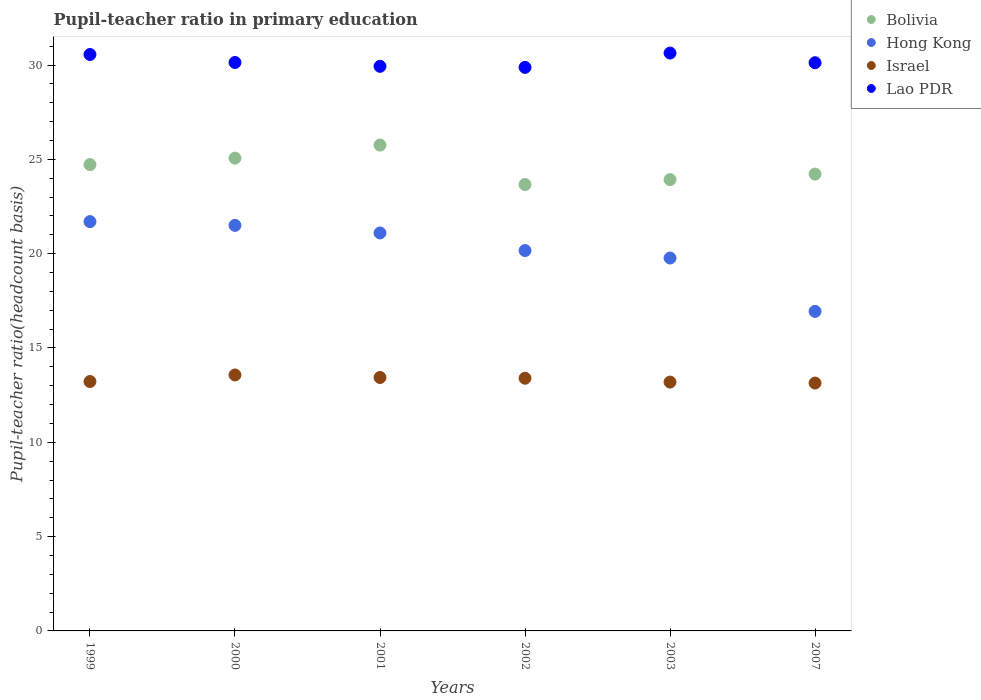Is the number of dotlines equal to the number of legend labels?
Ensure brevity in your answer.  Yes. What is the pupil-teacher ratio in primary education in Israel in 2001?
Your answer should be compact. 13.44. Across all years, what is the maximum pupil-teacher ratio in primary education in Lao PDR?
Keep it short and to the point. 30.64. Across all years, what is the minimum pupil-teacher ratio in primary education in Lao PDR?
Make the answer very short. 29.88. What is the total pupil-teacher ratio in primary education in Hong Kong in the graph?
Provide a short and direct response. 121.18. What is the difference between the pupil-teacher ratio in primary education in Hong Kong in 2001 and that in 2007?
Offer a very short reply. 4.16. What is the difference between the pupil-teacher ratio in primary education in Hong Kong in 2001 and the pupil-teacher ratio in primary education in Israel in 2007?
Offer a very short reply. 7.96. What is the average pupil-teacher ratio in primary education in Israel per year?
Provide a short and direct response. 13.33. In the year 1999, what is the difference between the pupil-teacher ratio in primary education in Israel and pupil-teacher ratio in primary education in Bolivia?
Offer a terse response. -11.5. In how many years, is the pupil-teacher ratio in primary education in Bolivia greater than 23?
Your response must be concise. 6. What is the ratio of the pupil-teacher ratio in primary education in Lao PDR in 2000 to that in 2003?
Your response must be concise. 0.98. Is the pupil-teacher ratio in primary education in Lao PDR in 2001 less than that in 2003?
Provide a succinct answer. Yes. Is the difference between the pupil-teacher ratio in primary education in Israel in 2000 and 2007 greater than the difference between the pupil-teacher ratio in primary education in Bolivia in 2000 and 2007?
Offer a very short reply. No. What is the difference between the highest and the second highest pupil-teacher ratio in primary education in Hong Kong?
Provide a short and direct response. 0.2. What is the difference between the highest and the lowest pupil-teacher ratio in primary education in Bolivia?
Make the answer very short. 2.09. Is the sum of the pupil-teacher ratio in primary education in Bolivia in 1999 and 2000 greater than the maximum pupil-teacher ratio in primary education in Hong Kong across all years?
Give a very brief answer. Yes. Is it the case that in every year, the sum of the pupil-teacher ratio in primary education in Bolivia and pupil-teacher ratio in primary education in Lao PDR  is greater than the sum of pupil-teacher ratio in primary education in Hong Kong and pupil-teacher ratio in primary education in Israel?
Offer a very short reply. Yes. Is the pupil-teacher ratio in primary education in Lao PDR strictly greater than the pupil-teacher ratio in primary education in Israel over the years?
Offer a terse response. Yes. Is the pupil-teacher ratio in primary education in Bolivia strictly less than the pupil-teacher ratio in primary education in Lao PDR over the years?
Keep it short and to the point. Yes. Where does the legend appear in the graph?
Ensure brevity in your answer.  Top right. How many legend labels are there?
Your answer should be very brief. 4. What is the title of the graph?
Provide a short and direct response. Pupil-teacher ratio in primary education. What is the label or title of the X-axis?
Ensure brevity in your answer.  Years. What is the label or title of the Y-axis?
Provide a short and direct response. Pupil-teacher ratio(headcount basis). What is the Pupil-teacher ratio(headcount basis) in Bolivia in 1999?
Give a very brief answer. 24.72. What is the Pupil-teacher ratio(headcount basis) of Hong Kong in 1999?
Provide a short and direct response. 21.7. What is the Pupil-teacher ratio(headcount basis) in Israel in 1999?
Provide a succinct answer. 13.22. What is the Pupil-teacher ratio(headcount basis) of Lao PDR in 1999?
Give a very brief answer. 30.56. What is the Pupil-teacher ratio(headcount basis) in Bolivia in 2000?
Give a very brief answer. 25.07. What is the Pupil-teacher ratio(headcount basis) of Hong Kong in 2000?
Your answer should be very brief. 21.5. What is the Pupil-teacher ratio(headcount basis) in Israel in 2000?
Your response must be concise. 13.57. What is the Pupil-teacher ratio(headcount basis) of Lao PDR in 2000?
Give a very brief answer. 30.14. What is the Pupil-teacher ratio(headcount basis) in Bolivia in 2001?
Make the answer very short. 25.76. What is the Pupil-teacher ratio(headcount basis) in Hong Kong in 2001?
Your answer should be compact. 21.1. What is the Pupil-teacher ratio(headcount basis) of Israel in 2001?
Give a very brief answer. 13.44. What is the Pupil-teacher ratio(headcount basis) of Lao PDR in 2001?
Provide a succinct answer. 29.93. What is the Pupil-teacher ratio(headcount basis) in Bolivia in 2002?
Give a very brief answer. 23.67. What is the Pupil-teacher ratio(headcount basis) in Hong Kong in 2002?
Provide a succinct answer. 20.17. What is the Pupil-teacher ratio(headcount basis) of Israel in 2002?
Offer a terse response. 13.4. What is the Pupil-teacher ratio(headcount basis) in Lao PDR in 2002?
Offer a terse response. 29.88. What is the Pupil-teacher ratio(headcount basis) in Bolivia in 2003?
Ensure brevity in your answer.  23.93. What is the Pupil-teacher ratio(headcount basis) of Hong Kong in 2003?
Offer a terse response. 19.77. What is the Pupil-teacher ratio(headcount basis) in Israel in 2003?
Your response must be concise. 13.19. What is the Pupil-teacher ratio(headcount basis) of Lao PDR in 2003?
Offer a very short reply. 30.64. What is the Pupil-teacher ratio(headcount basis) of Bolivia in 2007?
Offer a very short reply. 24.22. What is the Pupil-teacher ratio(headcount basis) of Hong Kong in 2007?
Your answer should be compact. 16.94. What is the Pupil-teacher ratio(headcount basis) in Israel in 2007?
Ensure brevity in your answer.  13.14. What is the Pupil-teacher ratio(headcount basis) in Lao PDR in 2007?
Your answer should be compact. 30.12. Across all years, what is the maximum Pupil-teacher ratio(headcount basis) of Bolivia?
Your answer should be very brief. 25.76. Across all years, what is the maximum Pupil-teacher ratio(headcount basis) of Hong Kong?
Ensure brevity in your answer.  21.7. Across all years, what is the maximum Pupil-teacher ratio(headcount basis) in Israel?
Give a very brief answer. 13.57. Across all years, what is the maximum Pupil-teacher ratio(headcount basis) of Lao PDR?
Provide a short and direct response. 30.64. Across all years, what is the minimum Pupil-teacher ratio(headcount basis) in Bolivia?
Offer a terse response. 23.67. Across all years, what is the minimum Pupil-teacher ratio(headcount basis) in Hong Kong?
Keep it short and to the point. 16.94. Across all years, what is the minimum Pupil-teacher ratio(headcount basis) in Israel?
Your answer should be compact. 13.14. Across all years, what is the minimum Pupil-teacher ratio(headcount basis) in Lao PDR?
Offer a terse response. 29.88. What is the total Pupil-teacher ratio(headcount basis) in Bolivia in the graph?
Offer a terse response. 147.36. What is the total Pupil-teacher ratio(headcount basis) of Hong Kong in the graph?
Provide a short and direct response. 121.18. What is the total Pupil-teacher ratio(headcount basis) in Israel in the graph?
Make the answer very short. 79.96. What is the total Pupil-teacher ratio(headcount basis) in Lao PDR in the graph?
Give a very brief answer. 181.27. What is the difference between the Pupil-teacher ratio(headcount basis) in Bolivia in 1999 and that in 2000?
Make the answer very short. -0.34. What is the difference between the Pupil-teacher ratio(headcount basis) of Hong Kong in 1999 and that in 2000?
Offer a terse response. 0.2. What is the difference between the Pupil-teacher ratio(headcount basis) of Israel in 1999 and that in 2000?
Make the answer very short. -0.35. What is the difference between the Pupil-teacher ratio(headcount basis) of Lao PDR in 1999 and that in 2000?
Offer a very short reply. 0.42. What is the difference between the Pupil-teacher ratio(headcount basis) of Bolivia in 1999 and that in 2001?
Your answer should be very brief. -1.04. What is the difference between the Pupil-teacher ratio(headcount basis) in Hong Kong in 1999 and that in 2001?
Offer a very short reply. 0.6. What is the difference between the Pupil-teacher ratio(headcount basis) of Israel in 1999 and that in 2001?
Your answer should be very brief. -0.21. What is the difference between the Pupil-teacher ratio(headcount basis) in Lao PDR in 1999 and that in 2001?
Offer a terse response. 0.63. What is the difference between the Pupil-teacher ratio(headcount basis) in Bolivia in 1999 and that in 2002?
Provide a succinct answer. 1.06. What is the difference between the Pupil-teacher ratio(headcount basis) in Hong Kong in 1999 and that in 2002?
Provide a succinct answer. 1.53. What is the difference between the Pupil-teacher ratio(headcount basis) of Israel in 1999 and that in 2002?
Offer a very short reply. -0.17. What is the difference between the Pupil-teacher ratio(headcount basis) in Lao PDR in 1999 and that in 2002?
Offer a very short reply. 0.68. What is the difference between the Pupil-teacher ratio(headcount basis) of Bolivia in 1999 and that in 2003?
Offer a very short reply. 0.8. What is the difference between the Pupil-teacher ratio(headcount basis) of Hong Kong in 1999 and that in 2003?
Your response must be concise. 1.93. What is the difference between the Pupil-teacher ratio(headcount basis) of Israel in 1999 and that in 2003?
Your answer should be compact. 0.03. What is the difference between the Pupil-teacher ratio(headcount basis) of Lao PDR in 1999 and that in 2003?
Ensure brevity in your answer.  -0.08. What is the difference between the Pupil-teacher ratio(headcount basis) of Bolivia in 1999 and that in 2007?
Ensure brevity in your answer.  0.5. What is the difference between the Pupil-teacher ratio(headcount basis) in Hong Kong in 1999 and that in 2007?
Ensure brevity in your answer.  4.76. What is the difference between the Pupil-teacher ratio(headcount basis) in Israel in 1999 and that in 2007?
Your response must be concise. 0.08. What is the difference between the Pupil-teacher ratio(headcount basis) in Lao PDR in 1999 and that in 2007?
Your answer should be compact. 0.44. What is the difference between the Pupil-teacher ratio(headcount basis) of Bolivia in 2000 and that in 2001?
Make the answer very short. -0.69. What is the difference between the Pupil-teacher ratio(headcount basis) in Hong Kong in 2000 and that in 2001?
Provide a short and direct response. 0.4. What is the difference between the Pupil-teacher ratio(headcount basis) in Israel in 2000 and that in 2001?
Your response must be concise. 0.13. What is the difference between the Pupil-teacher ratio(headcount basis) of Lao PDR in 2000 and that in 2001?
Offer a very short reply. 0.2. What is the difference between the Pupil-teacher ratio(headcount basis) in Bolivia in 2000 and that in 2002?
Provide a succinct answer. 1.4. What is the difference between the Pupil-teacher ratio(headcount basis) of Hong Kong in 2000 and that in 2002?
Your answer should be compact. 1.33. What is the difference between the Pupil-teacher ratio(headcount basis) of Israel in 2000 and that in 2002?
Make the answer very short. 0.17. What is the difference between the Pupil-teacher ratio(headcount basis) of Lao PDR in 2000 and that in 2002?
Your response must be concise. 0.26. What is the difference between the Pupil-teacher ratio(headcount basis) of Bolivia in 2000 and that in 2003?
Your answer should be very brief. 1.14. What is the difference between the Pupil-teacher ratio(headcount basis) of Hong Kong in 2000 and that in 2003?
Your response must be concise. 1.73. What is the difference between the Pupil-teacher ratio(headcount basis) of Israel in 2000 and that in 2003?
Ensure brevity in your answer.  0.38. What is the difference between the Pupil-teacher ratio(headcount basis) of Lao PDR in 2000 and that in 2003?
Your response must be concise. -0.5. What is the difference between the Pupil-teacher ratio(headcount basis) in Bolivia in 2000 and that in 2007?
Provide a succinct answer. 0.85. What is the difference between the Pupil-teacher ratio(headcount basis) in Hong Kong in 2000 and that in 2007?
Offer a very short reply. 4.56. What is the difference between the Pupil-teacher ratio(headcount basis) in Israel in 2000 and that in 2007?
Offer a terse response. 0.43. What is the difference between the Pupil-teacher ratio(headcount basis) in Lao PDR in 2000 and that in 2007?
Provide a succinct answer. 0.01. What is the difference between the Pupil-teacher ratio(headcount basis) of Bolivia in 2001 and that in 2002?
Your answer should be very brief. 2.09. What is the difference between the Pupil-teacher ratio(headcount basis) of Hong Kong in 2001 and that in 2002?
Ensure brevity in your answer.  0.93. What is the difference between the Pupil-teacher ratio(headcount basis) of Israel in 2001 and that in 2002?
Make the answer very short. 0.04. What is the difference between the Pupil-teacher ratio(headcount basis) of Lao PDR in 2001 and that in 2002?
Offer a very short reply. 0.06. What is the difference between the Pupil-teacher ratio(headcount basis) of Bolivia in 2001 and that in 2003?
Offer a terse response. 1.83. What is the difference between the Pupil-teacher ratio(headcount basis) in Hong Kong in 2001 and that in 2003?
Offer a terse response. 1.33. What is the difference between the Pupil-teacher ratio(headcount basis) of Israel in 2001 and that in 2003?
Make the answer very short. 0.24. What is the difference between the Pupil-teacher ratio(headcount basis) in Lao PDR in 2001 and that in 2003?
Offer a very short reply. -0.7. What is the difference between the Pupil-teacher ratio(headcount basis) of Bolivia in 2001 and that in 2007?
Provide a short and direct response. 1.54. What is the difference between the Pupil-teacher ratio(headcount basis) of Hong Kong in 2001 and that in 2007?
Provide a short and direct response. 4.16. What is the difference between the Pupil-teacher ratio(headcount basis) in Israel in 2001 and that in 2007?
Your answer should be very brief. 0.29. What is the difference between the Pupil-teacher ratio(headcount basis) of Lao PDR in 2001 and that in 2007?
Offer a very short reply. -0.19. What is the difference between the Pupil-teacher ratio(headcount basis) of Bolivia in 2002 and that in 2003?
Offer a terse response. -0.26. What is the difference between the Pupil-teacher ratio(headcount basis) of Hong Kong in 2002 and that in 2003?
Your answer should be very brief. 0.4. What is the difference between the Pupil-teacher ratio(headcount basis) in Israel in 2002 and that in 2003?
Make the answer very short. 0.2. What is the difference between the Pupil-teacher ratio(headcount basis) of Lao PDR in 2002 and that in 2003?
Make the answer very short. -0.76. What is the difference between the Pupil-teacher ratio(headcount basis) in Bolivia in 2002 and that in 2007?
Offer a very short reply. -0.55. What is the difference between the Pupil-teacher ratio(headcount basis) in Hong Kong in 2002 and that in 2007?
Provide a short and direct response. 3.23. What is the difference between the Pupil-teacher ratio(headcount basis) of Israel in 2002 and that in 2007?
Provide a succinct answer. 0.26. What is the difference between the Pupil-teacher ratio(headcount basis) in Lao PDR in 2002 and that in 2007?
Your answer should be compact. -0.25. What is the difference between the Pupil-teacher ratio(headcount basis) of Bolivia in 2003 and that in 2007?
Offer a terse response. -0.29. What is the difference between the Pupil-teacher ratio(headcount basis) in Hong Kong in 2003 and that in 2007?
Offer a very short reply. 2.83. What is the difference between the Pupil-teacher ratio(headcount basis) in Israel in 2003 and that in 2007?
Your response must be concise. 0.05. What is the difference between the Pupil-teacher ratio(headcount basis) of Lao PDR in 2003 and that in 2007?
Offer a very short reply. 0.51. What is the difference between the Pupil-teacher ratio(headcount basis) in Bolivia in 1999 and the Pupil-teacher ratio(headcount basis) in Hong Kong in 2000?
Make the answer very short. 3.22. What is the difference between the Pupil-teacher ratio(headcount basis) of Bolivia in 1999 and the Pupil-teacher ratio(headcount basis) of Israel in 2000?
Offer a terse response. 11.15. What is the difference between the Pupil-teacher ratio(headcount basis) in Bolivia in 1999 and the Pupil-teacher ratio(headcount basis) in Lao PDR in 2000?
Give a very brief answer. -5.41. What is the difference between the Pupil-teacher ratio(headcount basis) of Hong Kong in 1999 and the Pupil-teacher ratio(headcount basis) of Israel in 2000?
Give a very brief answer. 8.13. What is the difference between the Pupil-teacher ratio(headcount basis) in Hong Kong in 1999 and the Pupil-teacher ratio(headcount basis) in Lao PDR in 2000?
Make the answer very short. -8.44. What is the difference between the Pupil-teacher ratio(headcount basis) of Israel in 1999 and the Pupil-teacher ratio(headcount basis) of Lao PDR in 2000?
Make the answer very short. -16.91. What is the difference between the Pupil-teacher ratio(headcount basis) in Bolivia in 1999 and the Pupil-teacher ratio(headcount basis) in Hong Kong in 2001?
Provide a succinct answer. 3.62. What is the difference between the Pupil-teacher ratio(headcount basis) in Bolivia in 1999 and the Pupil-teacher ratio(headcount basis) in Israel in 2001?
Your answer should be very brief. 11.29. What is the difference between the Pupil-teacher ratio(headcount basis) in Bolivia in 1999 and the Pupil-teacher ratio(headcount basis) in Lao PDR in 2001?
Offer a terse response. -5.21. What is the difference between the Pupil-teacher ratio(headcount basis) of Hong Kong in 1999 and the Pupil-teacher ratio(headcount basis) of Israel in 2001?
Give a very brief answer. 8.26. What is the difference between the Pupil-teacher ratio(headcount basis) of Hong Kong in 1999 and the Pupil-teacher ratio(headcount basis) of Lao PDR in 2001?
Provide a short and direct response. -8.23. What is the difference between the Pupil-teacher ratio(headcount basis) in Israel in 1999 and the Pupil-teacher ratio(headcount basis) in Lao PDR in 2001?
Give a very brief answer. -16.71. What is the difference between the Pupil-teacher ratio(headcount basis) in Bolivia in 1999 and the Pupil-teacher ratio(headcount basis) in Hong Kong in 2002?
Your answer should be compact. 4.56. What is the difference between the Pupil-teacher ratio(headcount basis) of Bolivia in 1999 and the Pupil-teacher ratio(headcount basis) of Israel in 2002?
Your answer should be compact. 11.33. What is the difference between the Pupil-teacher ratio(headcount basis) of Bolivia in 1999 and the Pupil-teacher ratio(headcount basis) of Lao PDR in 2002?
Ensure brevity in your answer.  -5.15. What is the difference between the Pupil-teacher ratio(headcount basis) of Hong Kong in 1999 and the Pupil-teacher ratio(headcount basis) of Israel in 2002?
Your response must be concise. 8.3. What is the difference between the Pupil-teacher ratio(headcount basis) of Hong Kong in 1999 and the Pupil-teacher ratio(headcount basis) of Lao PDR in 2002?
Your answer should be very brief. -8.18. What is the difference between the Pupil-teacher ratio(headcount basis) of Israel in 1999 and the Pupil-teacher ratio(headcount basis) of Lao PDR in 2002?
Your answer should be very brief. -16.65. What is the difference between the Pupil-teacher ratio(headcount basis) of Bolivia in 1999 and the Pupil-teacher ratio(headcount basis) of Hong Kong in 2003?
Keep it short and to the point. 4.95. What is the difference between the Pupil-teacher ratio(headcount basis) of Bolivia in 1999 and the Pupil-teacher ratio(headcount basis) of Israel in 2003?
Offer a very short reply. 11.53. What is the difference between the Pupil-teacher ratio(headcount basis) in Bolivia in 1999 and the Pupil-teacher ratio(headcount basis) in Lao PDR in 2003?
Ensure brevity in your answer.  -5.91. What is the difference between the Pupil-teacher ratio(headcount basis) in Hong Kong in 1999 and the Pupil-teacher ratio(headcount basis) in Israel in 2003?
Your answer should be compact. 8.51. What is the difference between the Pupil-teacher ratio(headcount basis) of Hong Kong in 1999 and the Pupil-teacher ratio(headcount basis) of Lao PDR in 2003?
Provide a succinct answer. -8.94. What is the difference between the Pupil-teacher ratio(headcount basis) in Israel in 1999 and the Pupil-teacher ratio(headcount basis) in Lao PDR in 2003?
Provide a short and direct response. -17.41. What is the difference between the Pupil-teacher ratio(headcount basis) in Bolivia in 1999 and the Pupil-teacher ratio(headcount basis) in Hong Kong in 2007?
Offer a terse response. 7.78. What is the difference between the Pupil-teacher ratio(headcount basis) of Bolivia in 1999 and the Pupil-teacher ratio(headcount basis) of Israel in 2007?
Offer a terse response. 11.58. What is the difference between the Pupil-teacher ratio(headcount basis) of Bolivia in 1999 and the Pupil-teacher ratio(headcount basis) of Lao PDR in 2007?
Your answer should be very brief. -5.4. What is the difference between the Pupil-teacher ratio(headcount basis) of Hong Kong in 1999 and the Pupil-teacher ratio(headcount basis) of Israel in 2007?
Give a very brief answer. 8.56. What is the difference between the Pupil-teacher ratio(headcount basis) in Hong Kong in 1999 and the Pupil-teacher ratio(headcount basis) in Lao PDR in 2007?
Give a very brief answer. -8.42. What is the difference between the Pupil-teacher ratio(headcount basis) of Israel in 1999 and the Pupil-teacher ratio(headcount basis) of Lao PDR in 2007?
Your answer should be compact. -16.9. What is the difference between the Pupil-teacher ratio(headcount basis) of Bolivia in 2000 and the Pupil-teacher ratio(headcount basis) of Hong Kong in 2001?
Your response must be concise. 3.97. What is the difference between the Pupil-teacher ratio(headcount basis) of Bolivia in 2000 and the Pupil-teacher ratio(headcount basis) of Israel in 2001?
Provide a succinct answer. 11.63. What is the difference between the Pupil-teacher ratio(headcount basis) in Bolivia in 2000 and the Pupil-teacher ratio(headcount basis) in Lao PDR in 2001?
Make the answer very short. -4.87. What is the difference between the Pupil-teacher ratio(headcount basis) in Hong Kong in 2000 and the Pupil-teacher ratio(headcount basis) in Israel in 2001?
Ensure brevity in your answer.  8.06. What is the difference between the Pupil-teacher ratio(headcount basis) of Hong Kong in 2000 and the Pupil-teacher ratio(headcount basis) of Lao PDR in 2001?
Give a very brief answer. -8.43. What is the difference between the Pupil-teacher ratio(headcount basis) in Israel in 2000 and the Pupil-teacher ratio(headcount basis) in Lao PDR in 2001?
Ensure brevity in your answer.  -16.36. What is the difference between the Pupil-teacher ratio(headcount basis) in Bolivia in 2000 and the Pupil-teacher ratio(headcount basis) in Hong Kong in 2002?
Offer a terse response. 4.9. What is the difference between the Pupil-teacher ratio(headcount basis) in Bolivia in 2000 and the Pupil-teacher ratio(headcount basis) in Israel in 2002?
Ensure brevity in your answer.  11.67. What is the difference between the Pupil-teacher ratio(headcount basis) of Bolivia in 2000 and the Pupil-teacher ratio(headcount basis) of Lao PDR in 2002?
Provide a succinct answer. -4.81. What is the difference between the Pupil-teacher ratio(headcount basis) of Hong Kong in 2000 and the Pupil-teacher ratio(headcount basis) of Israel in 2002?
Provide a succinct answer. 8.1. What is the difference between the Pupil-teacher ratio(headcount basis) in Hong Kong in 2000 and the Pupil-teacher ratio(headcount basis) in Lao PDR in 2002?
Provide a succinct answer. -8.38. What is the difference between the Pupil-teacher ratio(headcount basis) of Israel in 2000 and the Pupil-teacher ratio(headcount basis) of Lao PDR in 2002?
Keep it short and to the point. -16.31. What is the difference between the Pupil-teacher ratio(headcount basis) in Bolivia in 2000 and the Pupil-teacher ratio(headcount basis) in Hong Kong in 2003?
Your response must be concise. 5.3. What is the difference between the Pupil-teacher ratio(headcount basis) in Bolivia in 2000 and the Pupil-teacher ratio(headcount basis) in Israel in 2003?
Offer a very short reply. 11.87. What is the difference between the Pupil-teacher ratio(headcount basis) in Bolivia in 2000 and the Pupil-teacher ratio(headcount basis) in Lao PDR in 2003?
Your response must be concise. -5.57. What is the difference between the Pupil-teacher ratio(headcount basis) of Hong Kong in 2000 and the Pupil-teacher ratio(headcount basis) of Israel in 2003?
Give a very brief answer. 8.31. What is the difference between the Pupil-teacher ratio(headcount basis) in Hong Kong in 2000 and the Pupil-teacher ratio(headcount basis) in Lao PDR in 2003?
Offer a terse response. -9.14. What is the difference between the Pupil-teacher ratio(headcount basis) of Israel in 2000 and the Pupil-teacher ratio(headcount basis) of Lao PDR in 2003?
Ensure brevity in your answer.  -17.07. What is the difference between the Pupil-teacher ratio(headcount basis) in Bolivia in 2000 and the Pupil-teacher ratio(headcount basis) in Hong Kong in 2007?
Make the answer very short. 8.12. What is the difference between the Pupil-teacher ratio(headcount basis) of Bolivia in 2000 and the Pupil-teacher ratio(headcount basis) of Israel in 2007?
Offer a terse response. 11.92. What is the difference between the Pupil-teacher ratio(headcount basis) in Bolivia in 2000 and the Pupil-teacher ratio(headcount basis) in Lao PDR in 2007?
Your response must be concise. -5.06. What is the difference between the Pupil-teacher ratio(headcount basis) in Hong Kong in 2000 and the Pupil-teacher ratio(headcount basis) in Israel in 2007?
Provide a short and direct response. 8.36. What is the difference between the Pupil-teacher ratio(headcount basis) in Hong Kong in 2000 and the Pupil-teacher ratio(headcount basis) in Lao PDR in 2007?
Your answer should be compact. -8.62. What is the difference between the Pupil-teacher ratio(headcount basis) of Israel in 2000 and the Pupil-teacher ratio(headcount basis) of Lao PDR in 2007?
Your answer should be compact. -16.55. What is the difference between the Pupil-teacher ratio(headcount basis) of Bolivia in 2001 and the Pupil-teacher ratio(headcount basis) of Hong Kong in 2002?
Your answer should be very brief. 5.59. What is the difference between the Pupil-teacher ratio(headcount basis) in Bolivia in 2001 and the Pupil-teacher ratio(headcount basis) in Israel in 2002?
Your answer should be compact. 12.36. What is the difference between the Pupil-teacher ratio(headcount basis) in Bolivia in 2001 and the Pupil-teacher ratio(headcount basis) in Lao PDR in 2002?
Provide a short and direct response. -4.12. What is the difference between the Pupil-teacher ratio(headcount basis) of Hong Kong in 2001 and the Pupil-teacher ratio(headcount basis) of Israel in 2002?
Give a very brief answer. 7.7. What is the difference between the Pupil-teacher ratio(headcount basis) of Hong Kong in 2001 and the Pupil-teacher ratio(headcount basis) of Lao PDR in 2002?
Provide a succinct answer. -8.78. What is the difference between the Pupil-teacher ratio(headcount basis) in Israel in 2001 and the Pupil-teacher ratio(headcount basis) in Lao PDR in 2002?
Make the answer very short. -16.44. What is the difference between the Pupil-teacher ratio(headcount basis) of Bolivia in 2001 and the Pupil-teacher ratio(headcount basis) of Hong Kong in 2003?
Your answer should be compact. 5.99. What is the difference between the Pupil-teacher ratio(headcount basis) of Bolivia in 2001 and the Pupil-teacher ratio(headcount basis) of Israel in 2003?
Keep it short and to the point. 12.57. What is the difference between the Pupil-teacher ratio(headcount basis) of Bolivia in 2001 and the Pupil-teacher ratio(headcount basis) of Lao PDR in 2003?
Provide a short and direct response. -4.88. What is the difference between the Pupil-teacher ratio(headcount basis) in Hong Kong in 2001 and the Pupil-teacher ratio(headcount basis) in Israel in 2003?
Give a very brief answer. 7.91. What is the difference between the Pupil-teacher ratio(headcount basis) of Hong Kong in 2001 and the Pupil-teacher ratio(headcount basis) of Lao PDR in 2003?
Give a very brief answer. -9.54. What is the difference between the Pupil-teacher ratio(headcount basis) in Israel in 2001 and the Pupil-teacher ratio(headcount basis) in Lao PDR in 2003?
Ensure brevity in your answer.  -17.2. What is the difference between the Pupil-teacher ratio(headcount basis) of Bolivia in 2001 and the Pupil-teacher ratio(headcount basis) of Hong Kong in 2007?
Your response must be concise. 8.82. What is the difference between the Pupil-teacher ratio(headcount basis) in Bolivia in 2001 and the Pupil-teacher ratio(headcount basis) in Israel in 2007?
Keep it short and to the point. 12.62. What is the difference between the Pupil-teacher ratio(headcount basis) of Bolivia in 2001 and the Pupil-teacher ratio(headcount basis) of Lao PDR in 2007?
Ensure brevity in your answer.  -4.36. What is the difference between the Pupil-teacher ratio(headcount basis) in Hong Kong in 2001 and the Pupil-teacher ratio(headcount basis) in Israel in 2007?
Provide a short and direct response. 7.96. What is the difference between the Pupil-teacher ratio(headcount basis) in Hong Kong in 2001 and the Pupil-teacher ratio(headcount basis) in Lao PDR in 2007?
Ensure brevity in your answer.  -9.03. What is the difference between the Pupil-teacher ratio(headcount basis) of Israel in 2001 and the Pupil-teacher ratio(headcount basis) of Lao PDR in 2007?
Your response must be concise. -16.69. What is the difference between the Pupil-teacher ratio(headcount basis) of Bolivia in 2002 and the Pupil-teacher ratio(headcount basis) of Hong Kong in 2003?
Make the answer very short. 3.9. What is the difference between the Pupil-teacher ratio(headcount basis) in Bolivia in 2002 and the Pupil-teacher ratio(headcount basis) in Israel in 2003?
Provide a succinct answer. 10.48. What is the difference between the Pupil-teacher ratio(headcount basis) of Bolivia in 2002 and the Pupil-teacher ratio(headcount basis) of Lao PDR in 2003?
Ensure brevity in your answer.  -6.97. What is the difference between the Pupil-teacher ratio(headcount basis) in Hong Kong in 2002 and the Pupil-teacher ratio(headcount basis) in Israel in 2003?
Provide a succinct answer. 6.97. What is the difference between the Pupil-teacher ratio(headcount basis) of Hong Kong in 2002 and the Pupil-teacher ratio(headcount basis) of Lao PDR in 2003?
Your response must be concise. -10.47. What is the difference between the Pupil-teacher ratio(headcount basis) in Israel in 2002 and the Pupil-teacher ratio(headcount basis) in Lao PDR in 2003?
Offer a very short reply. -17.24. What is the difference between the Pupil-teacher ratio(headcount basis) in Bolivia in 2002 and the Pupil-teacher ratio(headcount basis) in Hong Kong in 2007?
Provide a succinct answer. 6.73. What is the difference between the Pupil-teacher ratio(headcount basis) of Bolivia in 2002 and the Pupil-teacher ratio(headcount basis) of Israel in 2007?
Make the answer very short. 10.53. What is the difference between the Pupil-teacher ratio(headcount basis) in Bolivia in 2002 and the Pupil-teacher ratio(headcount basis) in Lao PDR in 2007?
Your response must be concise. -6.46. What is the difference between the Pupil-teacher ratio(headcount basis) in Hong Kong in 2002 and the Pupil-teacher ratio(headcount basis) in Israel in 2007?
Keep it short and to the point. 7.03. What is the difference between the Pupil-teacher ratio(headcount basis) in Hong Kong in 2002 and the Pupil-teacher ratio(headcount basis) in Lao PDR in 2007?
Provide a short and direct response. -9.96. What is the difference between the Pupil-teacher ratio(headcount basis) in Israel in 2002 and the Pupil-teacher ratio(headcount basis) in Lao PDR in 2007?
Your answer should be very brief. -16.73. What is the difference between the Pupil-teacher ratio(headcount basis) in Bolivia in 2003 and the Pupil-teacher ratio(headcount basis) in Hong Kong in 2007?
Your answer should be compact. 6.99. What is the difference between the Pupil-teacher ratio(headcount basis) in Bolivia in 2003 and the Pupil-teacher ratio(headcount basis) in Israel in 2007?
Your answer should be compact. 10.79. What is the difference between the Pupil-teacher ratio(headcount basis) in Bolivia in 2003 and the Pupil-teacher ratio(headcount basis) in Lao PDR in 2007?
Make the answer very short. -6.2. What is the difference between the Pupil-teacher ratio(headcount basis) of Hong Kong in 2003 and the Pupil-teacher ratio(headcount basis) of Israel in 2007?
Provide a short and direct response. 6.63. What is the difference between the Pupil-teacher ratio(headcount basis) in Hong Kong in 2003 and the Pupil-teacher ratio(headcount basis) in Lao PDR in 2007?
Provide a succinct answer. -10.35. What is the difference between the Pupil-teacher ratio(headcount basis) of Israel in 2003 and the Pupil-teacher ratio(headcount basis) of Lao PDR in 2007?
Your response must be concise. -16.93. What is the average Pupil-teacher ratio(headcount basis) in Bolivia per year?
Your response must be concise. 24.56. What is the average Pupil-teacher ratio(headcount basis) of Hong Kong per year?
Make the answer very short. 20.2. What is the average Pupil-teacher ratio(headcount basis) of Israel per year?
Your response must be concise. 13.33. What is the average Pupil-teacher ratio(headcount basis) of Lao PDR per year?
Offer a very short reply. 30.21. In the year 1999, what is the difference between the Pupil-teacher ratio(headcount basis) in Bolivia and Pupil-teacher ratio(headcount basis) in Hong Kong?
Offer a terse response. 3.02. In the year 1999, what is the difference between the Pupil-teacher ratio(headcount basis) of Bolivia and Pupil-teacher ratio(headcount basis) of Israel?
Provide a succinct answer. 11.5. In the year 1999, what is the difference between the Pupil-teacher ratio(headcount basis) in Bolivia and Pupil-teacher ratio(headcount basis) in Lao PDR?
Ensure brevity in your answer.  -5.84. In the year 1999, what is the difference between the Pupil-teacher ratio(headcount basis) of Hong Kong and Pupil-teacher ratio(headcount basis) of Israel?
Your answer should be compact. 8.48. In the year 1999, what is the difference between the Pupil-teacher ratio(headcount basis) in Hong Kong and Pupil-teacher ratio(headcount basis) in Lao PDR?
Make the answer very short. -8.86. In the year 1999, what is the difference between the Pupil-teacher ratio(headcount basis) in Israel and Pupil-teacher ratio(headcount basis) in Lao PDR?
Provide a short and direct response. -17.34. In the year 2000, what is the difference between the Pupil-teacher ratio(headcount basis) in Bolivia and Pupil-teacher ratio(headcount basis) in Hong Kong?
Keep it short and to the point. 3.57. In the year 2000, what is the difference between the Pupil-teacher ratio(headcount basis) of Bolivia and Pupil-teacher ratio(headcount basis) of Israel?
Offer a terse response. 11.49. In the year 2000, what is the difference between the Pupil-teacher ratio(headcount basis) of Bolivia and Pupil-teacher ratio(headcount basis) of Lao PDR?
Provide a succinct answer. -5.07. In the year 2000, what is the difference between the Pupil-teacher ratio(headcount basis) in Hong Kong and Pupil-teacher ratio(headcount basis) in Israel?
Provide a succinct answer. 7.93. In the year 2000, what is the difference between the Pupil-teacher ratio(headcount basis) in Hong Kong and Pupil-teacher ratio(headcount basis) in Lao PDR?
Your answer should be very brief. -8.64. In the year 2000, what is the difference between the Pupil-teacher ratio(headcount basis) in Israel and Pupil-teacher ratio(headcount basis) in Lao PDR?
Ensure brevity in your answer.  -16.57. In the year 2001, what is the difference between the Pupil-teacher ratio(headcount basis) in Bolivia and Pupil-teacher ratio(headcount basis) in Hong Kong?
Your answer should be very brief. 4.66. In the year 2001, what is the difference between the Pupil-teacher ratio(headcount basis) in Bolivia and Pupil-teacher ratio(headcount basis) in Israel?
Provide a short and direct response. 12.32. In the year 2001, what is the difference between the Pupil-teacher ratio(headcount basis) of Bolivia and Pupil-teacher ratio(headcount basis) of Lao PDR?
Offer a terse response. -4.17. In the year 2001, what is the difference between the Pupil-teacher ratio(headcount basis) in Hong Kong and Pupil-teacher ratio(headcount basis) in Israel?
Offer a terse response. 7.66. In the year 2001, what is the difference between the Pupil-teacher ratio(headcount basis) of Hong Kong and Pupil-teacher ratio(headcount basis) of Lao PDR?
Offer a terse response. -8.83. In the year 2001, what is the difference between the Pupil-teacher ratio(headcount basis) in Israel and Pupil-teacher ratio(headcount basis) in Lao PDR?
Provide a short and direct response. -16.5. In the year 2002, what is the difference between the Pupil-teacher ratio(headcount basis) in Bolivia and Pupil-teacher ratio(headcount basis) in Hong Kong?
Keep it short and to the point. 3.5. In the year 2002, what is the difference between the Pupil-teacher ratio(headcount basis) in Bolivia and Pupil-teacher ratio(headcount basis) in Israel?
Give a very brief answer. 10.27. In the year 2002, what is the difference between the Pupil-teacher ratio(headcount basis) in Bolivia and Pupil-teacher ratio(headcount basis) in Lao PDR?
Provide a succinct answer. -6.21. In the year 2002, what is the difference between the Pupil-teacher ratio(headcount basis) of Hong Kong and Pupil-teacher ratio(headcount basis) of Israel?
Offer a very short reply. 6.77. In the year 2002, what is the difference between the Pupil-teacher ratio(headcount basis) of Hong Kong and Pupil-teacher ratio(headcount basis) of Lao PDR?
Make the answer very short. -9.71. In the year 2002, what is the difference between the Pupil-teacher ratio(headcount basis) of Israel and Pupil-teacher ratio(headcount basis) of Lao PDR?
Provide a short and direct response. -16.48. In the year 2003, what is the difference between the Pupil-teacher ratio(headcount basis) in Bolivia and Pupil-teacher ratio(headcount basis) in Hong Kong?
Your response must be concise. 4.16. In the year 2003, what is the difference between the Pupil-teacher ratio(headcount basis) in Bolivia and Pupil-teacher ratio(headcount basis) in Israel?
Offer a terse response. 10.74. In the year 2003, what is the difference between the Pupil-teacher ratio(headcount basis) of Bolivia and Pupil-teacher ratio(headcount basis) of Lao PDR?
Your answer should be compact. -6.71. In the year 2003, what is the difference between the Pupil-teacher ratio(headcount basis) in Hong Kong and Pupil-teacher ratio(headcount basis) in Israel?
Give a very brief answer. 6.58. In the year 2003, what is the difference between the Pupil-teacher ratio(headcount basis) in Hong Kong and Pupil-teacher ratio(headcount basis) in Lao PDR?
Offer a terse response. -10.87. In the year 2003, what is the difference between the Pupil-teacher ratio(headcount basis) of Israel and Pupil-teacher ratio(headcount basis) of Lao PDR?
Give a very brief answer. -17.44. In the year 2007, what is the difference between the Pupil-teacher ratio(headcount basis) of Bolivia and Pupil-teacher ratio(headcount basis) of Hong Kong?
Make the answer very short. 7.28. In the year 2007, what is the difference between the Pupil-teacher ratio(headcount basis) in Bolivia and Pupil-teacher ratio(headcount basis) in Israel?
Give a very brief answer. 11.08. In the year 2007, what is the difference between the Pupil-teacher ratio(headcount basis) of Bolivia and Pupil-teacher ratio(headcount basis) of Lao PDR?
Your answer should be very brief. -5.91. In the year 2007, what is the difference between the Pupil-teacher ratio(headcount basis) of Hong Kong and Pupil-teacher ratio(headcount basis) of Israel?
Keep it short and to the point. 3.8. In the year 2007, what is the difference between the Pupil-teacher ratio(headcount basis) of Hong Kong and Pupil-teacher ratio(headcount basis) of Lao PDR?
Provide a succinct answer. -13.18. In the year 2007, what is the difference between the Pupil-teacher ratio(headcount basis) in Israel and Pupil-teacher ratio(headcount basis) in Lao PDR?
Give a very brief answer. -16.98. What is the ratio of the Pupil-teacher ratio(headcount basis) in Bolivia in 1999 to that in 2000?
Ensure brevity in your answer.  0.99. What is the ratio of the Pupil-teacher ratio(headcount basis) of Hong Kong in 1999 to that in 2000?
Your answer should be compact. 1.01. What is the ratio of the Pupil-teacher ratio(headcount basis) in Israel in 1999 to that in 2000?
Offer a terse response. 0.97. What is the ratio of the Pupil-teacher ratio(headcount basis) of Lao PDR in 1999 to that in 2000?
Provide a succinct answer. 1.01. What is the ratio of the Pupil-teacher ratio(headcount basis) in Bolivia in 1999 to that in 2001?
Make the answer very short. 0.96. What is the ratio of the Pupil-teacher ratio(headcount basis) in Hong Kong in 1999 to that in 2001?
Ensure brevity in your answer.  1.03. What is the ratio of the Pupil-teacher ratio(headcount basis) of Israel in 1999 to that in 2001?
Your answer should be very brief. 0.98. What is the ratio of the Pupil-teacher ratio(headcount basis) of Lao PDR in 1999 to that in 2001?
Provide a short and direct response. 1.02. What is the ratio of the Pupil-teacher ratio(headcount basis) in Bolivia in 1999 to that in 2002?
Your answer should be compact. 1.04. What is the ratio of the Pupil-teacher ratio(headcount basis) in Hong Kong in 1999 to that in 2002?
Offer a terse response. 1.08. What is the ratio of the Pupil-teacher ratio(headcount basis) in Israel in 1999 to that in 2002?
Offer a very short reply. 0.99. What is the ratio of the Pupil-teacher ratio(headcount basis) of Lao PDR in 1999 to that in 2002?
Give a very brief answer. 1.02. What is the ratio of the Pupil-teacher ratio(headcount basis) of Hong Kong in 1999 to that in 2003?
Your response must be concise. 1.1. What is the ratio of the Pupil-teacher ratio(headcount basis) in Israel in 1999 to that in 2003?
Keep it short and to the point. 1. What is the ratio of the Pupil-teacher ratio(headcount basis) of Bolivia in 1999 to that in 2007?
Your answer should be very brief. 1.02. What is the ratio of the Pupil-teacher ratio(headcount basis) of Hong Kong in 1999 to that in 2007?
Provide a succinct answer. 1.28. What is the ratio of the Pupil-teacher ratio(headcount basis) of Lao PDR in 1999 to that in 2007?
Your answer should be very brief. 1.01. What is the ratio of the Pupil-teacher ratio(headcount basis) of Hong Kong in 2000 to that in 2001?
Give a very brief answer. 1.02. What is the ratio of the Pupil-teacher ratio(headcount basis) of Lao PDR in 2000 to that in 2001?
Your answer should be very brief. 1.01. What is the ratio of the Pupil-teacher ratio(headcount basis) of Bolivia in 2000 to that in 2002?
Offer a very short reply. 1.06. What is the ratio of the Pupil-teacher ratio(headcount basis) in Hong Kong in 2000 to that in 2002?
Your answer should be very brief. 1.07. What is the ratio of the Pupil-teacher ratio(headcount basis) in Israel in 2000 to that in 2002?
Ensure brevity in your answer.  1.01. What is the ratio of the Pupil-teacher ratio(headcount basis) of Lao PDR in 2000 to that in 2002?
Provide a succinct answer. 1.01. What is the ratio of the Pupil-teacher ratio(headcount basis) of Bolivia in 2000 to that in 2003?
Keep it short and to the point. 1.05. What is the ratio of the Pupil-teacher ratio(headcount basis) of Hong Kong in 2000 to that in 2003?
Keep it short and to the point. 1.09. What is the ratio of the Pupil-teacher ratio(headcount basis) of Israel in 2000 to that in 2003?
Your response must be concise. 1.03. What is the ratio of the Pupil-teacher ratio(headcount basis) in Lao PDR in 2000 to that in 2003?
Ensure brevity in your answer.  0.98. What is the ratio of the Pupil-teacher ratio(headcount basis) in Bolivia in 2000 to that in 2007?
Give a very brief answer. 1.03. What is the ratio of the Pupil-teacher ratio(headcount basis) of Hong Kong in 2000 to that in 2007?
Ensure brevity in your answer.  1.27. What is the ratio of the Pupil-teacher ratio(headcount basis) of Israel in 2000 to that in 2007?
Your response must be concise. 1.03. What is the ratio of the Pupil-teacher ratio(headcount basis) of Lao PDR in 2000 to that in 2007?
Make the answer very short. 1. What is the ratio of the Pupil-teacher ratio(headcount basis) of Bolivia in 2001 to that in 2002?
Make the answer very short. 1.09. What is the ratio of the Pupil-teacher ratio(headcount basis) of Hong Kong in 2001 to that in 2002?
Ensure brevity in your answer.  1.05. What is the ratio of the Pupil-teacher ratio(headcount basis) of Lao PDR in 2001 to that in 2002?
Ensure brevity in your answer.  1. What is the ratio of the Pupil-teacher ratio(headcount basis) in Bolivia in 2001 to that in 2003?
Your response must be concise. 1.08. What is the ratio of the Pupil-teacher ratio(headcount basis) in Hong Kong in 2001 to that in 2003?
Your answer should be compact. 1.07. What is the ratio of the Pupil-teacher ratio(headcount basis) of Israel in 2001 to that in 2003?
Give a very brief answer. 1.02. What is the ratio of the Pupil-teacher ratio(headcount basis) in Lao PDR in 2001 to that in 2003?
Ensure brevity in your answer.  0.98. What is the ratio of the Pupil-teacher ratio(headcount basis) in Bolivia in 2001 to that in 2007?
Provide a succinct answer. 1.06. What is the ratio of the Pupil-teacher ratio(headcount basis) in Hong Kong in 2001 to that in 2007?
Offer a terse response. 1.25. What is the ratio of the Pupil-teacher ratio(headcount basis) of Israel in 2001 to that in 2007?
Keep it short and to the point. 1.02. What is the ratio of the Pupil-teacher ratio(headcount basis) of Hong Kong in 2002 to that in 2003?
Offer a very short reply. 1.02. What is the ratio of the Pupil-teacher ratio(headcount basis) of Israel in 2002 to that in 2003?
Provide a succinct answer. 1.02. What is the ratio of the Pupil-teacher ratio(headcount basis) in Lao PDR in 2002 to that in 2003?
Your answer should be very brief. 0.98. What is the ratio of the Pupil-teacher ratio(headcount basis) in Bolivia in 2002 to that in 2007?
Make the answer very short. 0.98. What is the ratio of the Pupil-teacher ratio(headcount basis) in Hong Kong in 2002 to that in 2007?
Keep it short and to the point. 1.19. What is the ratio of the Pupil-teacher ratio(headcount basis) in Israel in 2002 to that in 2007?
Your response must be concise. 1.02. What is the ratio of the Pupil-teacher ratio(headcount basis) in Lao PDR in 2002 to that in 2007?
Your answer should be very brief. 0.99. What is the ratio of the Pupil-teacher ratio(headcount basis) of Hong Kong in 2003 to that in 2007?
Provide a short and direct response. 1.17. What is the difference between the highest and the second highest Pupil-teacher ratio(headcount basis) in Bolivia?
Your answer should be compact. 0.69. What is the difference between the highest and the second highest Pupil-teacher ratio(headcount basis) of Israel?
Keep it short and to the point. 0.13. What is the difference between the highest and the second highest Pupil-teacher ratio(headcount basis) in Lao PDR?
Provide a succinct answer. 0.08. What is the difference between the highest and the lowest Pupil-teacher ratio(headcount basis) in Bolivia?
Your response must be concise. 2.09. What is the difference between the highest and the lowest Pupil-teacher ratio(headcount basis) of Hong Kong?
Give a very brief answer. 4.76. What is the difference between the highest and the lowest Pupil-teacher ratio(headcount basis) of Israel?
Your answer should be compact. 0.43. What is the difference between the highest and the lowest Pupil-teacher ratio(headcount basis) in Lao PDR?
Give a very brief answer. 0.76. 